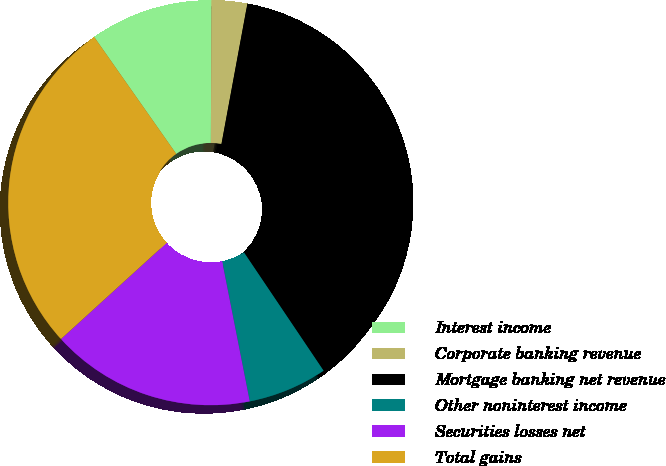Convert chart. <chart><loc_0><loc_0><loc_500><loc_500><pie_chart><fcel>Interest income<fcel>Corporate banking revenue<fcel>Mortgage banking net revenue<fcel>Other noninterest income<fcel>Securities losses net<fcel>Total gains<nl><fcel>9.81%<fcel>2.84%<fcel>37.67%<fcel>6.33%<fcel>16.35%<fcel>27.01%<nl></chart> 